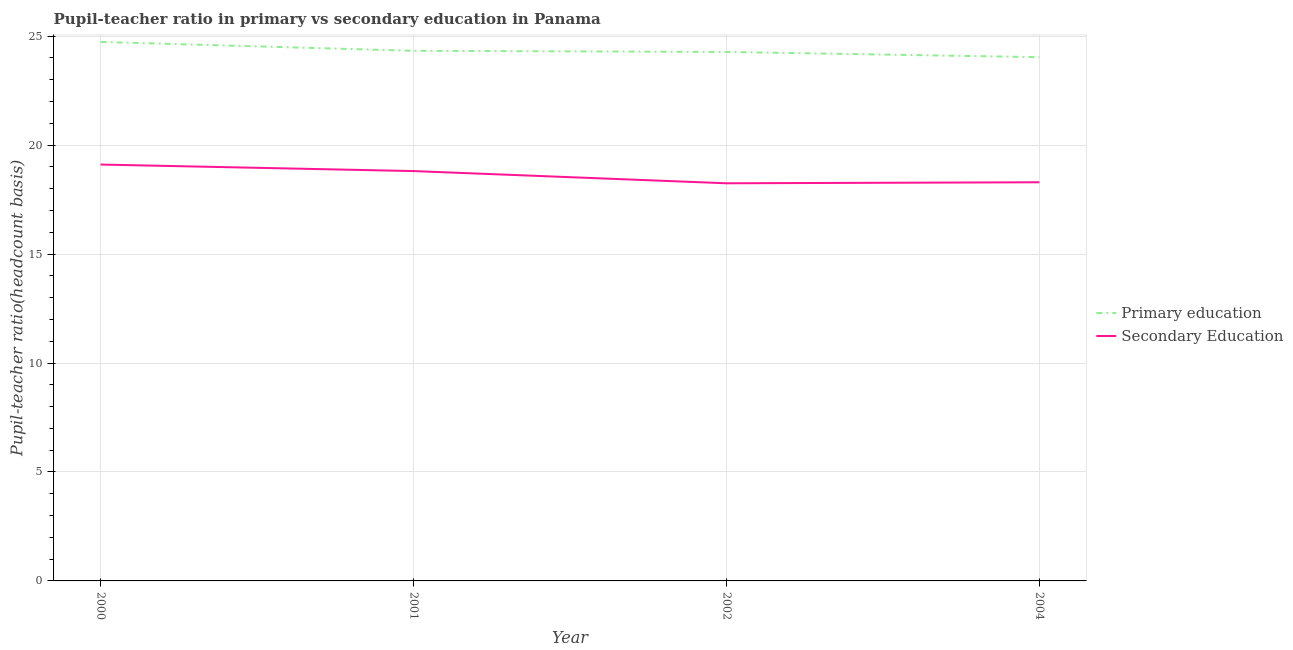Does the line corresponding to pupil teacher ratio on secondary education intersect with the line corresponding to pupil-teacher ratio in primary education?
Your answer should be compact. No. What is the pupil-teacher ratio in primary education in 2002?
Your response must be concise. 24.28. Across all years, what is the maximum pupil teacher ratio on secondary education?
Keep it short and to the point. 19.11. Across all years, what is the minimum pupil-teacher ratio in primary education?
Offer a very short reply. 24.04. In which year was the pupil teacher ratio on secondary education minimum?
Give a very brief answer. 2002. What is the total pupil teacher ratio on secondary education in the graph?
Give a very brief answer. 74.46. What is the difference between the pupil teacher ratio on secondary education in 2000 and that in 2004?
Your answer should be very brief. 0.81. What is the difference between the pupil-teacher ratio in primary education in 2004 and the pupil teacher ratio on secondary education in 2000?
Provide a short and direct response. 4.93. What is the average pupil teacher ratio on secondary education per year?
Make the answer very short. 18.62. In the year 2001, what is the difference between the pupil teacher ratio on secondary education and pupil-teacher ratio in primary education?
Offer a terse response. -5.52. What is the ratio of the pupil-teacher ratio in primary education in 2001 to that in 2004?
Offer a very short reply. 1.01. Is the pupil-teacher ratio in primary education in 2001 less than that in 2004?
Offer a very short reply. No. Is the difference between the pupil-teacher ratio in primary education in 2001 and 2004 greater than the difference between the pupil teacher ratio on secondary education in 2001 and 2004?
Offer a very short reply. No. What is the difference between the highest and the second highest pupil teacher ratio on secondary education?
Make the answer very short. 0.3. What is the difference between the highest and the lowest pupil teacher ratio on secondary education?
Offer a terse response. 0.86. In how many years, is the pupil teacher ratio on secondary education greater than the average pupil teacher ratio on secondary education taken over all years?
Give a very brief answer. 2. Is the pupil-teacher ratio in primary education strictly greater than the pupil teacher ratio on secondary education over the years?
Make the answer very short. Yes. Is the pupil teacher ratio on secondary education strictly less than the pupil-teacher ratio in primary education over the years?
Provide a short and direct response. Yes. How many lines are there?
Your answer should be compact. 2. Does the graph contain any zero values?
Offer a very short reply. No. Does the graph contain grids?
Offer a very short reply. Yes. Where does the legend appear in the graph?
Keep it short and to the point. Center right. How many legend labels are there?
Give a very brief answer. 2. What is the title of the graph?
Your answer should be compact. Pupil-teacher ratio in primary vs secondary education in Panama. What is the label or title of the X-axis?
Offer a very short reply. Year. What is the label or title of the Y-axis?
Your answer should be very brief. Pupil-teacher ratio(headcount basis). What is the Pupil-teacher ratio(headcount basis) of Primary education in 2000?
Your response must be concise. 24.74. What is the Pupil-teacher ratio(headcount basis) of Secondary Education in 2000?
Make the answer very short. 19.11. What is the Pupil-teacher ratio(headcount basis) of Primary education in 2001?
Ensure brevity in your answer.  24.33. What is the Pupil-teacher ratio(headcount basis) of Secondary Education in 2001?
Provide a succinct answer. 18.81. What is the Pupil-teacher ratio(headcount basis) of Primary education in 2002?
Provide a short and direct response. 24.28. What is the Pupil-teacher ratio(headcount basis) in Secondary Education in 2002?
Provide a short and direct response. 18.25. What is the Pupil-teacher ratio(headcount basis) in Primary education in 2004?
Ensure brevity in your answer.  24.04. What is the Pupil-teacher ratio(headcount basis) of Secondary Education in 2004?
Your answer should be compact. 18.3. Across all years, what is the maximum Pupil-teacher ratio(headcount basis) in Primary education?
Offer a terse response. 24.74. Across all years, what is the maximum Pupil-teacher ratio(headcount basis) of Secondary Education?
Offer a very short reply. 19.11. Across all years, what is the minimum Pupil-teacher ratio(headcount basis) in Primary education?
Your answer should be compact. 24.04. Across all years, what is the minimum Pupil-teacher ratio(headcount basis) of Secondary Education?
Your answer should be very brief. 18.25. What is the total Pupil-teacher ratio(headcount basis) in Primary education in the graph?
Keep it short and to the point. 97.38. What is the total Pupil-teacher ratio(headcount basis) of Secondary Education in the graph?
Your response must be concise. 74.46. What is the difference between the Pupil-teacher ratio(headcount basis) in Primary education in 2000 and that in 2001?
Your response must be concise. 0.41. What is the difference between the Pupil-teacher ratio(headcount basis) of Secondary Education in 2000 and that in 2001?
Your answer should be very brief. 0.3. What is the difference between the Pupil-teacher ratio(headcount basis) of Primary education in 2000 and that in 2002?
Offer a terse response. 0.46. What is the difference between the Pupil-teacher ratio(headcount basis) in Secondary Education in 2000 and that in 2002?
Ensure brevity in your answer.  0.86. What is the difference between the Pupil-teacher ratio(headcount basis) in Primary education in 2000 and that in 2004?
Your answer should be very brief. 0.7. What is the difference between the Pupil-teacher ratio(headcount basis) of Secondary Education in 2000 and that in 2004?
Provide a succinct answer. 0.81. What is the difference between the Pupil-teacher ratio(headcount basis) in Primary education in 2001 and that in 2002?
Make the answer very short. 0.05. What is the difference between the Pupil-teacher ratio(headcount basis) in Secondary Education in 2001 and that in 2002?
Provide a short and direct response. 0.56. What is the difference between the Pupil-teacher ratio(headcount basis) of Primary education in 2001 and that in 2004?
Keep it short and to the point. 0.29. What is the difference between the Pupil-teacher ratio(headcount basis) of Secondary Education in 2001 and that in 2004?
Give a very brief answer. 0.51. What is the difference between the Pupil-teacher ratio(headcount basis) of Primary education in 2002 and that in 2004?
Keep it short and to the point. 0.24. What is the difference between the Pupil-teacher ratio(headcount basis) of Secondary Education in 2002 and that in 2004?
Your answer should be compact. -0.05. What is the difference between the Pupil-teacher ratio(headcount basis) in Primary education in 2000 and the Pupil-teacher ratio(headcount basis) in Secondary Education in 2001?
Offer a terse response. 5.93. What is the difference between the Pupil-teacher ratio(headcount basis) in Primary education in 2000 and the Pupil-teacher ratio(headcount basis) in Secondary Education in 2002?
Ensure brevity in your answer.  6.49. What is the difference between the Pupil-teacher ratio(headcount basis) in Primary education in 2000 and the Pupil-teacher ratio(headcount basis) in Secondary Education in 2004?
Your answer should be compact. 6.44. What is the difference between the Pupil-teacher ratio(headcount basis) in Primary education in 2001 and the Pupil-teacher ratio(headcount basis) in Secondary Education in 2002?
Your answer should be very brief. 6.08. What is the difference between the Pupil-teacher ratio(headcount basis) of Primary education in 2001 and the Pupil-teacher ratio(headcount basis) of Secondary Education in 2004?
Provide a short and direct response. 6.03. What is the difference between the Pupil-teacher ratio(headcount basis) in Primary education in 2002 and the Pupil-teacher ratio(headcount basis) in Secondary Education in 2004?
Your answer should be compact. 5.98. What is the average Pupil-teacher ratio(headcount basis) of Primary education per year?
Provide a short and direct response. 24.35. What is the average Pupil-teacher ratio(headcount basis) of Secondary Education per year?
Make the answer very short. 18.62. In the year 2000, what is the difference between the Pupil-teacher ratio(headcount basis) in Primary education and Pupil-teacher ratio(headcount basis) in Secondary Education?
Provide a succinct answer. 5.63. In the year 2001, what is the difference between the Pupil-teacher ratio(headcount basis) of Primary education and Pupil-teacher ratio(headcount basis) of Secondary Education?
Make the answer very short. 5.52. In the year 2002, what is the difference between the Pupil-teacher ratio(headcount basis) in Primary education and Pupil-teacher ratio(headcount basis) in Secondary Education?
Make the answer very short. 6.03. In the year 2004, what is the difference between the Pupil-teacher ratio(headcount basis) in Primary education and Pupil-teacher ratio(headcount basis) in Secondary Education?
Offer a very short reply. 5.74. What is the ratio of the Pupil-teacher ratio(headcount basis) in Primary education in 2000 to that in 2001?
Your answer should be very brief. 1.02. What is the ratio of the Pupil-teacher ratio(headcount basis) in Secondary Education in 2000 to that in 2001?
Provide a short and direct response. 1.02. What is the ratio of the Pupil-teacher ratio(headcount basis) of Primary education in 2000 to that in 2002?
Offer a terse response. 1.02. What is the ratio of the Pupil-teacher ratio(headcount basis) in Secondary Education in 2000 to that in 2002?
Your answer should be very brief. 1.05. What is the ratio of the Pupil-teacher ratio(headcount basis) of Primary education in 2000 to that in 2004?
Provide a succinct answer. 1.03. What is the ratio of the Pupil-teacher ratio(headcount basis) in Secondary Education in 2000 to that in 2004?
Give a very brief answer. 1.04. What is the ratio of the Pupil-teacher ratio(headcount basis) in Secondary Education in 2001 to that in 2002?
Your response must be concise. 1.03. What is the ratio of the Pupil-teacher ratio(headcount basis) of Primary education in 2001 to that in 2004?
Provide a short and direct response. 1.01. What is the ratio of the Pupil-teacher ratio(headcount basis) in Secondary Education in 2001 to that in 2004?
Ensure brevity in your answer.  1.03. What is the ratio of the Pupil-teacher ratio(headcount basis) of Secondary Education in 2002 to that in 2004?
Give a very brief answer. 1. What is the difference between the highest and the second highest Pupil-teacher ratio(headcount basis) of Primary education?
Make the answer very short. 0.41. What is the difference between the highest and the second highest Pupil-teacher ratio(headcount basis) in Secondary Education?
Offer a very short reply. 0.3. What is the difference between the highest and the lowest Pupil-teacher ratio(headcount basis) in Primary education?
Keep it short and to the point. 0.7. What is the difference between the highest and the lowest Pupil-teacher ratio(headcount basis) of Secondary Education?
Your answer should be compact. 0.86. 